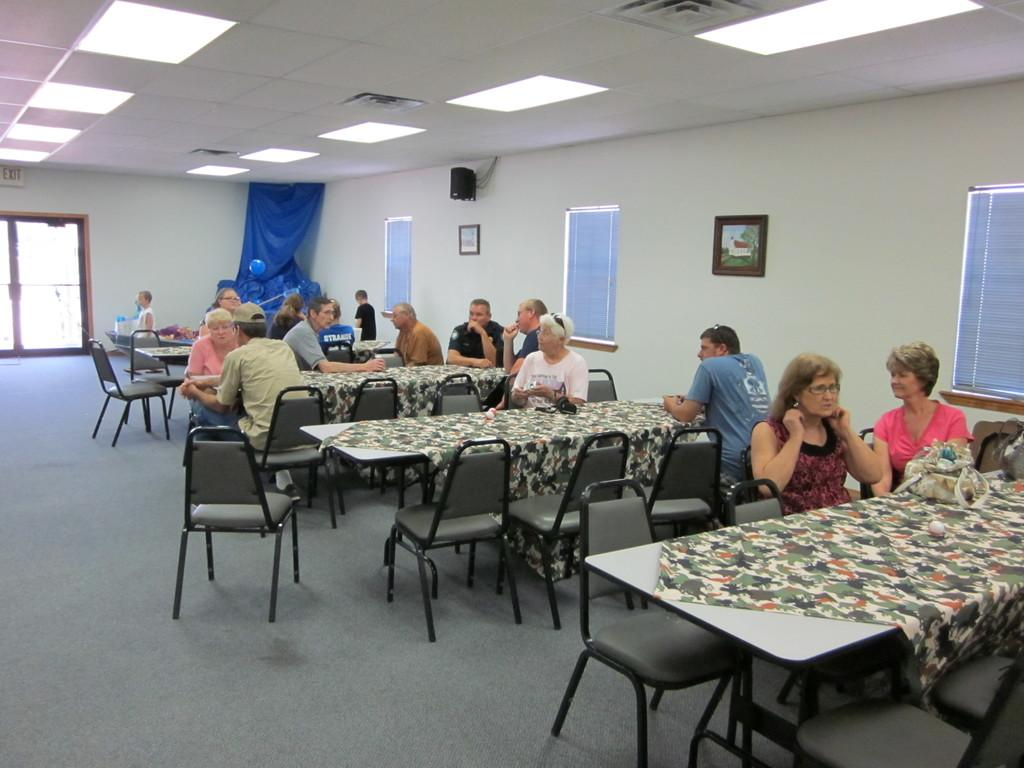What are the persons in the room doing? The persons in the room are sitting on chairs. What can be seen at the top of the image? There is a sound box at the top of the image. What is attached to the wall in the room? Paintings are attached to the wall. What type of liquid is being poured from the vessel in the image? There is no vessel or liquid present in the image. Can you describe the rat's behavior in the image? There is no rat present in the image. 